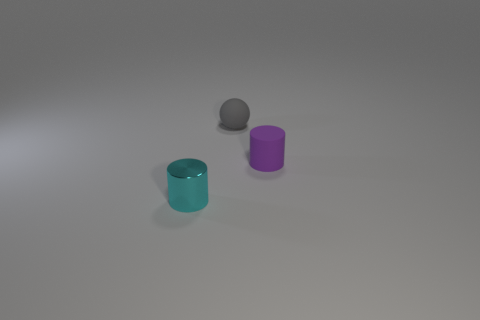Add 3 tiny matte objects. How many objects exist? 6 Subtract all tiny matte balls. Subtract all purple cylinders. How many objects are left? 1 Add 2 small gray spheres. How many small gray spheres are left? 3 Add 3 purple rubber things. How many purple rubber things exist? 4 Subtract all cyan cylinders. How many cylinders are left? 1 Subtract 0 gray cubes. How many objects are left? 3 Subtract all cylinders. How many objects are left? 1 Subtract all green cylinders. Subtract all purple blocks. How many cylinders are left? 2 Subtract all gray spheres. How many red cylinders are left? 0 